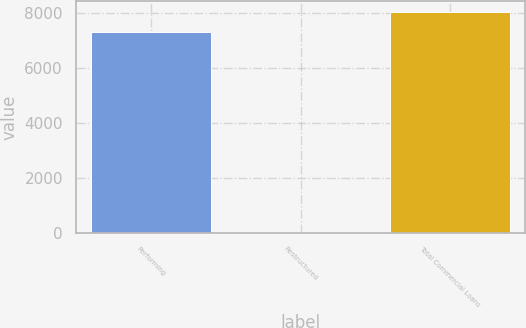<chart> <loc_0><loc_0><loc_500><loc_500><bar_chart><fcel>Performing<fcel>Restructured<fcel>Total Commercial Loans<nl><fcel>7298<fcel>1<fcel>8027.9<nl></chart> 